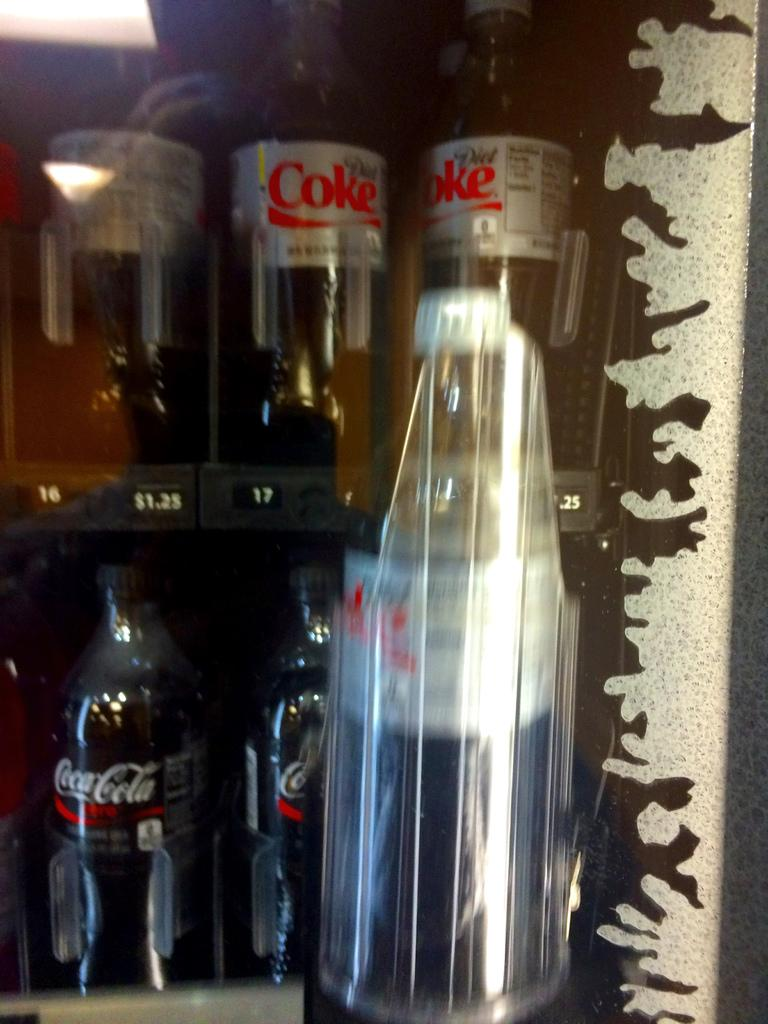What is the main subject of the picture? The picture is mainly highlighted with preservative drinking bottles. Can you describe the main objects in the image? The main objects in the image are preservative drinking bottles. Is there a volcano erupting in the background of the image? There is no volcano or any indication of an eruption in the image; it features preservative drinking bottles. How many people are working together to create the preservative drinking bottles in the image? There is no information about people or any work-related activity in the image; it only shows preservative drinking bottles. 